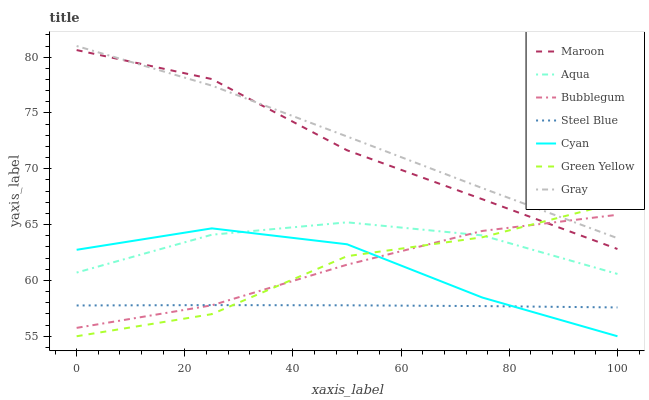Does Steel Blue have the minimum area under the curve?
Answer yes or no. Yes. Does Gray have the maximum area under the curve?
Answer yes or no. Yes. Does Aqua have the minimum area under the curve?
Answer yes or no. No. Does Aqua have the maximum area under the curve?
Answer yes or no. No. Is Steel Blue the smoothest?
Answer yes or no. Yes. Is Green Yellow the roughest?
Answer yes or no. Yes. Is Aqua the smoothest?
Answer yes or no. No. Is Aqua the roughest?
Answer yes or no. No. Does Cyan have the lowest value?
Answer yes or no. Yes. Does Aqua have the lowest value?
Answer yes or no. No. Does Gray have the highest value?
Answer yes or no. Yes. Does Aqua have the highest value?
Answer yes or no. No. Is Cyan less than Gray?
Answer yes or no. Yes. Is Maroon greater than Aqua?
Answer yes or no. Yes. Does Gray intersect Bubblegum?
Answer yes or no. Yes. Is Gray less than Bubblegum?
Answer yes or no. No. Is Gray greater than Bubblegum?
Answer yes or no. No. Does Cyan intersect Gray?
Answer yes or no. No. 